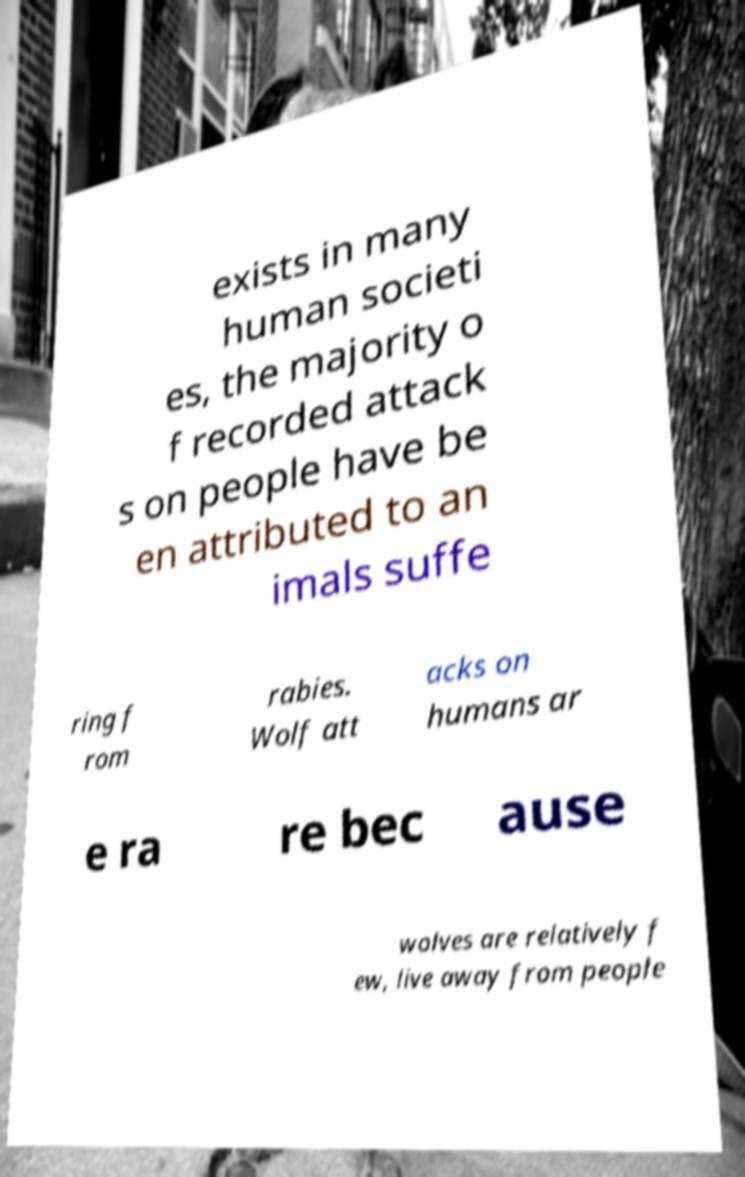What messages or text are displayed in this image? I need them in a readable, typed format. exists in many human societi es, the majority o f recorded attack s on people have be en attributed to an imals suffe ring f rom rabies. Wolf att acks on humans ar e ra re bec ause wolves are relatively f ew, live away from people 